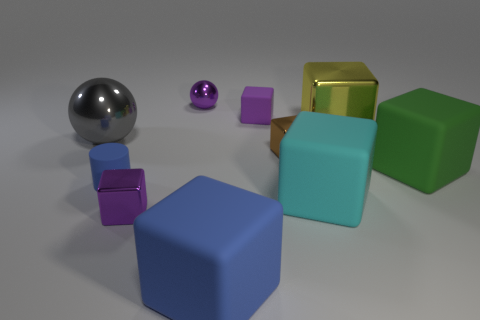The shiny object that is in front of the cube on the right side of the shiny block behind the large gray metal ball is what shape?
Your answer should be compact. Cube. The metallic block that is in front of the green cube is what color?
Make the answer very short. Purple. What number of objects are large spheres behind the big blue matte thing or metal things on the right side of the matte cylinder?
Provide a short and direct response. 5. What number of tiny shiny things have the same shape as the tiny blue matte thing?
Ensure brevity in your answer.  0. What color is the rubber cube that is the same size as the brown metallic thing?
Offer a very short reply. Purple. There is a block that is left of the ball that is to the right of the purple block that is in front of the big gray ball; what color is it?
Your response must be concise. Purple. Does the green cube have the same size as the purple block that is in front of the gray metallic ball?
Your answer should be compact. No. What number of things are either small rubber objects or purple matte blocks?
Your answer should be compact. 2. Are there any large gray balls made of the same material as the green object?
Make the answer very short. No. There is a rubber thing that is the same color as the small ball; what is its size?
Your answer should be very brief. Small. 